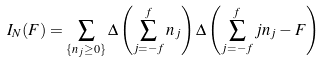Convert formula to latex. <formula><loc_0><loc_0><loc_500><loc_500>I _ { N } ( F ) = \sum _ { \{ n _ { j } \geq 0 \} } \Delta \left ( \sum _ { j = - f } ^ { f } n _ { j } \right ) \Delta \left ( \sum _ { j = - f } ^ { f } j n _ { j } - F \right )</formula> 